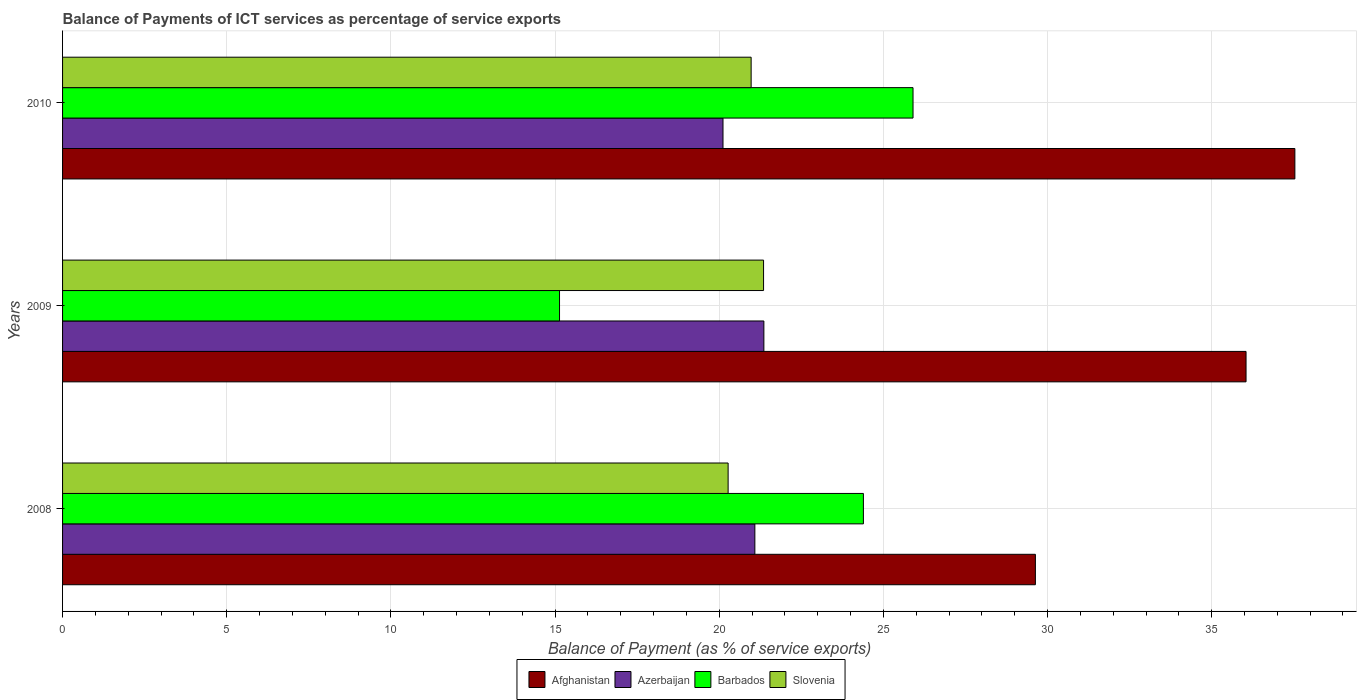How many different coloured bars are there?
Your response must be concise. 4. How many groups of bars are there?
Provide a short and direct response. 3. How many bars are there on the 3rd tick from the top?
Provide a short and direct response. 4. In how many cases, is the number of bars for a given year not equal to the number of legend labels?
Your answer should be compact. 0. What is the balance of payments of ICT services in Azerbaijan in 2009?
Offer a terse response. 21.36. Across all years, what is the maximum balance of payments of ICT services in Azerbaijan?
Offer a terse response. 21.36. Across all years, what is the minimum balance of payments of ICT services in Azerbaijan?
Give a very brief answer. 20.12. What is the total balance of payments of ICT services in Slovenia in the graph?
Give a very brief answer. 62.6. What is the difference between the balance of payments of ICT services in Azerbaijan in 2009 and that in 2010?
Keep it short and to the point. 1.25. What is the difference between the balance of payments of ICT services in Barbados in 2010 and the balance of payments of ICT services in Afghanistan in 2009?
Provide a succinct answer. -10.14. What is the average balance of payments of ICT services in Barbados per year?
Give a very brief answer. 21.81. In the year 2008, what is the difference between the balance of payments of ICT services in Barbados and balance of payments of ICT services in Afghanistan?
Your response must be concise. -5.24. What is the ratio of the balance of payments of ICT services in Azerbaijan in 2008 to that in 2009?
Offer a terse response. 0.99. Is the balance of payments of ICT services in Azerbaijan in 2009 less than that in 2010?
Give a very brief answer. No. Is the difference between the balance of payments of ICT services in Barbados in 2008 and 2010 greater than the difference between the balance of payments of ICT services in Afghanistan in 2008 and 2010?
Offer a terse response. Yes. What is the difference between the highest and the second highest balance of payments of ICT services in Afghanistan?
Keep it short and to the point. 1.49. What is the difference between the highest and the lowest balance of payments of ICT services in Azerbaijan?
Make the answer very short. 1.25. In how many years, is the balance of payments of ICT services in Slovenia greater than the average balance of payments of ICT services in Slovenia taken over all years?
Give a very brief answer. 2. What does the 2nd bar from the top in 2010 represents?
Keep it short and to the point. Barbados. What does the 4th bar from the bottom in 2008 represents?
Ensure brevity in your answer.  Slovenia. Is it the case that in every year, the sum of the balance of payments of ICT services in Barbados and balance of payments of ICT services in Afghanistan is greater than the balance of payments of ICT services in Azerbaijan?
Ensure brevity in your answer.  Yes. Are all the bars in the graph horizontal?
Ensure brevity in your answer.  Yes. Are the values on the major ticks of X-axis written in scientific E-notation?
Offer a very short reply. No. How many legend labels are there?
Provide a short and direct response. 4. How are the legend labels stacked?
Provide a short and direct response. Horizontal. What is the title of the graph?
Your answer should be compact. Balance of Payments of ICT services as percentage of service exports. Does "Russian Federation" appear as one of the legend labels in the graph?
Your answer should be compact. No. What is the label or title of the X-axis?
Ensure brevity in your answer.  Balance of Payment (as % of service exports). What is the Balance of Payment (as % of service exports) of Afghanistan in 2008?
Offer a terse response. 29.63. What is the Balance of Payment (as % of service exports) of Azerbaijan in 2008?
Provide a short and direct response. 21.09. What is the Balance of Payment (as % of service exports) in Barbados in 2008?
Provide a short and direct response. 24.39. What is the Balance of Payment (as % of service exports) of Slovenia in 2008?
Your response must be concise. 20.27. What is the Balance of Payment (as % of service exports) in Afghanistan in 2009?
Your response must be concise. 36.05. What is the Balance of Payment (as % of service exports) in Azerbaijan in 2009?
Provide a succinct answer. 21.36. What is the Balance of Payment (as % of service exports) of Barbados in 2009?
Your answer should be very brief. 15.14. What is the Balance of Payment (as % of service exports) of Slovenia in 2009?
Provide a succinct answer. 21.35. What is the Balance of Payment (as % of service exports) in Afghanistan in 2010?
Provide a succinct answer. 37.53. What is the Balance of Payment (as % of service exports) of Azerbaijan in 2010?
Provide a short and direct response. 20.12. What is the Balance of Payment (as % of service exports) in Barbados in 2010?
Provide a succinct answer. 25.9. What is the Balance of Payment (as % of service exports) in Slovenia in 2010?
Make the answer very short. 20.97. Across all years, what is the maximum Balance of Payment (as % of service exports) in Afghanistan?
Provide a succinct answer. 37.53. Across all years, what is the maximum Balance of Payment (as % of service exports) in Azerbaijan?
Offer a very short reply. 21.36. Across all years, what is the maximum Balance of Payment (as % of service exports) in Barbados?
Ensure brevity in your answer.  25.9. Across all years, what is the maximum Balance of Payment (as % of service exports) in Slovenia?
Give a very brief answer. 21.35. Across all years, what is the minimum Balance of Payment (as % of service exports) in Afghanistan?
Keep it short and to the point. 29.63. Across all years, what is the minimum Balance of Payment (as % of service exports) of Azerbaijan?
Offer a very short reply. 20.12. Across all years, what is the minimum Balance of Payment (as % of service exports) in Barbados?
Keep it short and to the point. 15.14. Across all years, what is the minimum Balance of Payment (as % of service exports) of Slovenia?
Offer a very short reply. 20.27. What is the total Balance of Payment (as % of service exports) in Afghanistan in the graph?
Ensure brevity in your answer.  103.21. What is the total Balance of Payment (as % of service exports) in Azerbaijan in the graph?
Offer a very short reply. 62.56. What is the total Balance of Payment (as % of service exports) of Barbados in the graph?
Your answer should be very brief. 65.43. What is the total Balance of Payment (as % of service exports) of Slovenia in the graph?
Your response must be concise. 62.6. What is the difference between the Balance of Payment (as % of service exports) in Afghanistan in 2008 and that in 2009?
Your answer should be compact. -6.42. What is the difference between the Balance of Payment (as % of service exports) in Azerbaijan in 2008 and that in 2009?
Your answer should be compact. -0.27. What is the difference between the Balance of Payment (as % of service exports) of Barbados in 2008 and that in 2009?
Offer a very short reply. 9.26. What is the difference between the Balance of Payment (as % of service exports) of Slovenia in 2008 and that in 2009?
Provide a short and direct response. -1.08. What is the difference between the Balance of Payment (as % of service exports) of Afghanistan in 2008 and that in 2010?
Ensure brevity in your answer.  -7.9. What is the difference between the Balance of Payment (as % of service exports) of Azerbaijan in 2008 and that in 2010?
Keep it short and to the point. 0.97. What is the difference between the Balance of Payment (as % of service exports) of Barbados in 2008 and that in 2010?
Make the answer very short. -1.51. What is the difference between the Balance of Payment (as % of service exports) in Slovenia in 2008 and that in 2010?
Keep it short and to the point. -0.7. What is the difference between the Balance of Payment (as % of service exports) in Afghanistan in 2009 and that in 2010?
Give a very brief answer. -1.49. What is the difference between the Balance of Payment (as % of service exports) in Azerbaijan in 2009 and that in 2010?
Your answer should be very brief. 1.25. What is the difference between the Balance of Payment (as % of service exports) of Barbados in 2009 and that in 2010?
Your response must be concise. -10.77. What is the difference between the Balance of Payment (as % of service exports) of Slovenia in 2009 and that in 2010?
Your answer should be very brief. 0.38. What is the difference between the Balance of Payment (as % of service exports) in Afghanistan in 2008 and the Balance of Payment (as % of service exports) in Azerbaijan in 2009?
Keep it short and to the point. 8.27. What is the difference between the Balance of Payment (as % of service exports) of Afghanistan in 2008 and the Balance of Payment (as % of service exports) of Barbados in 2009?
Your response must be concise. 14.49. What is the difference between the Balance of Payment (as % of service exports) in Afghanistan in 2008 and the Balance of Payment (as % of service exports) in Slovenia in 2009?
Provide a succinct answer. 8.28. What is the difference between the Balance of Payment (as % of service exports) of Azerbaijan in 2008 and the Balance of Payment (as % of service exports) of Barbados in 2009?
Provide a short and direct response. 5.95. What is the difference between the Balance of Payment (as % of service exports) of Azerbaijan in 2008 and the Balance of Payment (as % of service exports) of Slovenia in 2009?
Offer a terse response. -0.27. What is the difference between the Balance of Payment (as % of service exports) of Barbados in 2008 and the Balance of Payment (as % of service exports) of Slovenia in 2009?
Your response must be concise. 3.04. What is the difference between the Balance of Payment (as % of service exports) of Afghanistan in 2008 and the Balance of Payment (as % of service exports) of Azerbaijan in 2010?
Ensure brevity in your answer.  9.52. What is the difference between the Balance of Payment (as % of service exports) of Afghanistan in 2008 and the Balance of Payment (as % of service exports) of Barbados in 2010?
Provide a succinct answer. 3.73. What is the difference between the Balance of Payment (as % of service exports) in Afghanistan in 2008 and the Balance of Payment (as % of service exports) in Slovenia in 2010?
Your response must be concise. 8.66. What is the difference between the Balance of Payment (as % of service exports) of Azerbaijan in 2008 and the Balance of Payment (as % of service exports) of Barbados in 2010?
Give a very brief answer. -4.82. What is the difference between the Balance of Payment (as % of service exports) in Azerbaijan in 2008 and the Balance of Payment (as % of service exports) in Slovenia in 2010?
Give a very brief answer. 0.11. What is the difference between the Balance of Payment (as % of service exports) of Barbados in 2008 and the Balance of Payment (as % of service exports) of Slovenia in 2010?
Ensure brevity in your answer.  3.42. What is the difference between the Balance of Payment (as % of service exports) of Afghanistan in 2009 and the Balance of Payment (as % of service exports) of Azerbaijan in 2010?
Keep it short and to the point. 15.93. What is the difference between the Balance of Payment (as % of service exports) in Afghanistan in 2009 and the Balance of Payment (as % of service exports) in Barbados in 2010?
Keep it short and to the point. 10.14. What is the difference between the Balance of Payment (as % of service exports) of Afghanistan in 2009 and the Balance of Payment (as % of service exports) of Slovenia in 2010?
Provide a short and direct response. 15.07. What is the difference between the Balance of Payment (as % of service exports) in Azerbaijan in 2009 and the Balance of Payment (as % of service exports) in Barbados in 2010?
Keep it short and to the point. -4.54. What is the difference between the Balance of Payment (as % of service exports) of Azerbaijan in 2009 and the Balance of Payment (as % of service exports) of Slovenia in 2010?
Offer a terse response. 0.39. What is the difference between the Balance of Payment (as % of service exports) of Barbados in 2009 and the Balance of Payment (as % of service exports) of Slovenia in 2010?
Provide a succinct answer. -5.84. What is the average Balance of Payment (as % of service exports) of Afghanistan per year?
Offer a terse response. 34.4. What is the average Balance of Payment (as % of service exports) of Azerbaijan per year?
Offer a terse response. 20.85. What is the average Balance of Payment (as % of service exports) of Barbados per year?
Your answer should be very brief. 21.81. What is the average Balance of Payment (as % of service exports) in Slovenia per year?
Your response must be concise. 20.87. In the year 2008, what is the difference between the Balance of Payment (as % of service exports) of Afghanistan and Balance of Payment (as % of service exports) of Azerbaijan?
Your response must be concise. 8.54. In the year 2008, what is the difference between the Balance of Payment (as % of service exports) of Afghanistan and Balance of Payment (as % of service exports) of Barbados?
Your response must be concise. 5.24. In the year 2008, what is the difference between the Balance of Payment (as % of service exports) in Afghanistan and Balance of Payment (as % of service exports) in Slovenia?
Give a very brief answer. 9.36. In the year 2008, what is the difference between the Balance of Payment (as % of service exports) of Azerbaijan and Balance of Payment (as % of service exports) of Barbados?
Give a very brief answer. -3.31. In the year 2008, what is the difference between the Balance of Payment (as % of service exports) of Azerbaijan and Balance of Payment (as % of service exports) of Slovenia?
Ensure brevity in your answer.  0.81. In the year 2008, what is the difference between the Balance of Payment (as % of service exports) of Barbados and Balance of Payment (as % of service exports) of Slovenia?
Offer a terse response. 4.12. In the year 2009, what is the difference between the Balance of Payment (as % of service exports) of Afghanistan and Balance of Payment (as % of service exports) of Azerbaijan?
Give a very brief answer. 14.69. In the year 2009, what is the difference between the Balance of Payment (as % of service exports) of Afghanistan and Balance of Payment (as % of service exports) of Barbados?
Provide a short and direct response. 20.91. In the year 2009, what is the difference between the Balance of Payment (as % of service exports) of Afghanistan and Balance of Payment (as % of service exports) of Slovenia?
Your answer should be compact. 14.7. In the year 2009, what is the difference between the Balance of Payment (as % of service exports) in Azerbaijan and Balance of Payment (as % of service exports) in Barbados?
Offer a terse response. 6.22. In the year 2009, what is the difference between the Balance of Payment (as % of service exports) in Azerbaijan and Balance of Payment (as % of service exports) in Slovenia?
Offer a terse response. 0.01. In the year 2009, what is the difference between the Balance of Payment (as % of service exports) of Barbados and Balance of Payment (as % of service exports) of Slovenia?
Your answer should be compact. -6.21. In the year 2010, what is the difference between the Balance of Payment (as % of service exports) of Afghanistan and Balance of Payment (as % of service exports) of Azerbaijan?
Provide a short and direct response. 17.42. In the year 2010, what is the difference between the Balance of Payment (as % of service exports) in Afghanistan and Balance of Payment (as % of service exports) in Barbados?
Offer a terse response. 11.63. In the year 2010, what is the difference between the Balance of Payment (as % of service exports) in Afghanistan and Balance of Payment (as % of service exports) in Slovenia?
Provide a short and direct response. 16.56. In the year 2010, what is the difference between the Balance of Payment (as % of service exports) of Azerbaijan and Balance of Payment (as % of service exports) of Barbados?
Keep it short and to the point. -5.79. In the year 2010, what is the difference between the Balance of Payment (as % of service exports) in Azerbaijan and Balance of Payment (as % of service exports) in Slovenia?
Provide a short and direct response. -0.86. In the year 2010, what is the difference between the Balance of Payment (as % of service exports) of Barbados and Balance of Payment (as % of service exports) of Slovenia?
Give a very brief answer. 4.93. What is the ratio of the Balance of Payment (as % of service exports) in Afghanistan in 2008 to that in 2009?
Offer a terse response. 0.82. What is the ratio of the Balance of Payment (as % of service exports) in Azerbaijan in 2008 to that in 2009?
Offer a terse response. 0.99. What is the ratio of the Balance of Payment (as % of service exports) in Barbados in 2008 to that in 2009?
Provide a succinct answer. 1.61. What is the ratio of the Balance of Payment (as % of service exports) of Slovenia in 2008 to that in 2009?
Ensure brevity in your answer.  0.95. What is the ratio of the Balance of Payment (as % of service exports) in Afghanistan in 2008 to that in 2010?
Offer a very short reply. 0.79. What is the ratio of the Balance of Payment (as % of service exports) of Azerbaijan in 2008 to that in 2010?
Provide a succinct answer. 1.05. What is the ratio of the Balance of Payment (as % of service exports) in Barbados in 2008 to that in 2010?
Your answer should be compact. 0.94. What is the ratio of the Balance of Payment (as % of service exports) of Slovenia in 2008 to that in 2010?
Offer a terse response. 0.97. What is the ratio of the Balance of Payment (as % of service exports) in Afghanistan in 2009 to that in 2010?
Your answer should be very brief. 0.96. What is the ratio of the Balance of Payment (as % of service exports) of Azerbaijan in 2009 to that in 2010?
Your answer should be compact. 1.06. What is the ratio of the Balance of Payment (as % of service exports) of Barbados in 2009 to that in 2010?
Ensure brevity in your answer.  0.58. What is the ratio of the Balance of Payment (as % of service exports) in Slovenia in 2009 to that in 2010?
Give a very brief answer. 1.02. What is the difference between the highest and the second highest Balance of Payment (as % of service exports) in Afghanistan?
Provide a succinct answer. 1.49. What is the difference between the highest and the second highest Balance of Payment (as % of service exports) in Azerbaijan?
Provide a short and direct response. 0.27. What is the difference between the highest and the second highest Balance of Payment (as % of service exports) of Barbados?
Provide a succinct answer. 1.51. What is the difference between the highest and the second highest Balance of Payment (as % of service exports) of Slovenia?
Offer a terse response. 0.38. What is the difference between the highest and the lowest Balance of Payment (as % of service exports) in Afghanistan?
Ensure brevity in your answer.  7.9. What is the difference between the highest and the lowest Balance of Payment (as % of service exports) in Azerbaijan?
Provide a short and direct response. 1.25. What is the difference between the highest and the lowest Balance of Payment (as % of service exports) of Barbados?
Provide a short and direct response. 10.77. What is the difference between the highest and the lowest Balance of Payment (as % of service exports) in Slovenia?
Your answer should be compact. 1.08. 